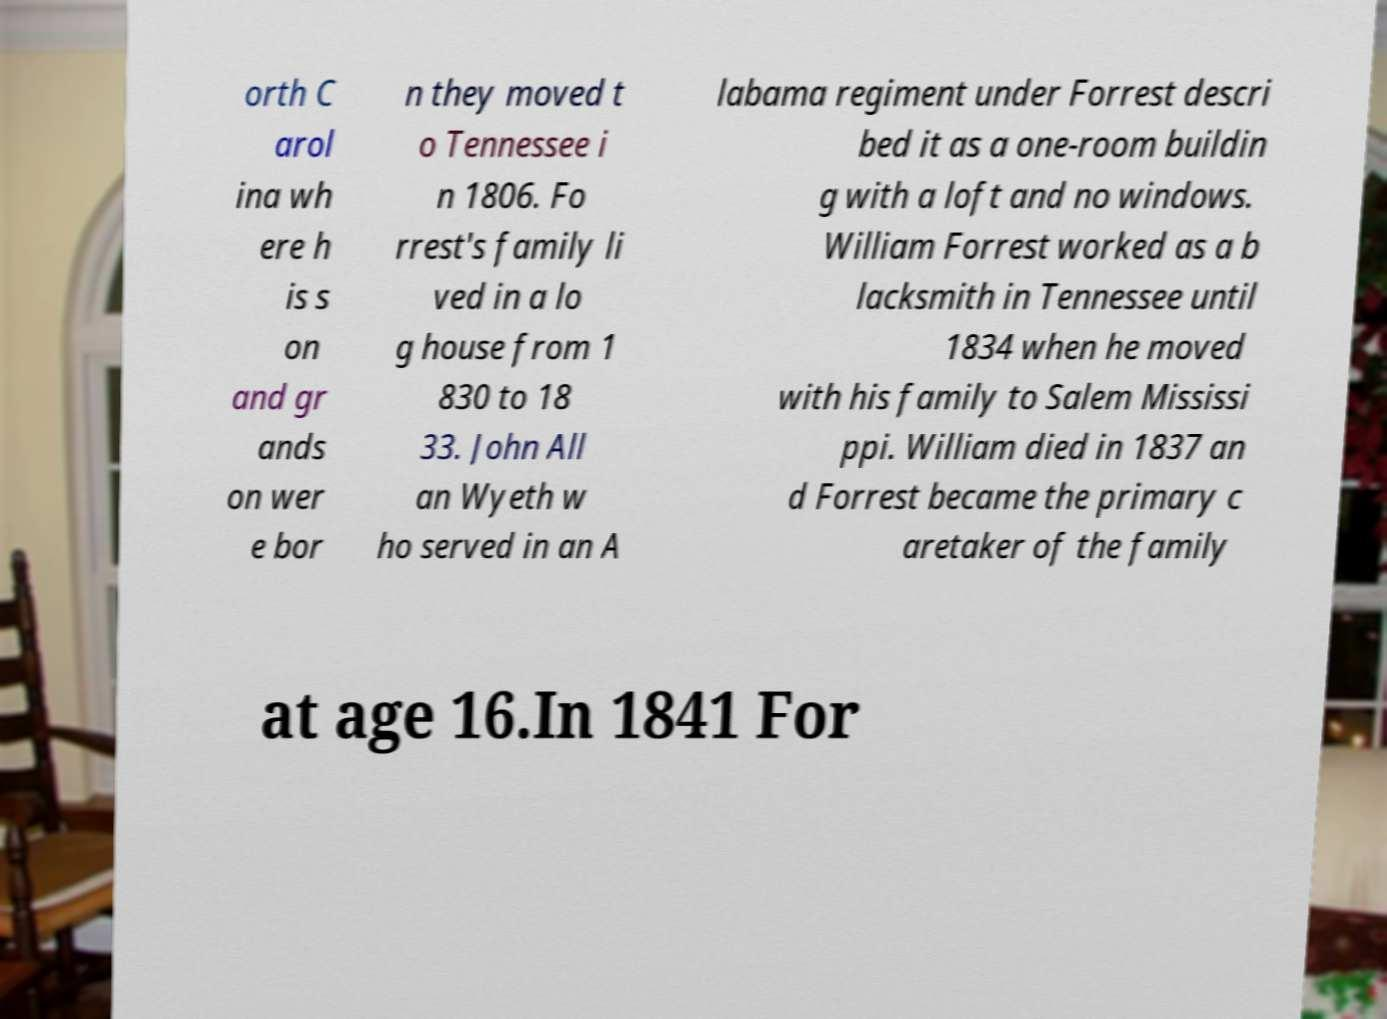Could you extract and type out the text from this image? orth C arol ina wh ere h is s on and gr ands on wer e bor n they moved t o Tennessee i n 1806. Fo rrest's family li ved in a lo g house from 1 830 to 18 33. John All an Wyeth w ho served in an A labama regiment under Forrest descri bed it as a one-room buildin g with a loft and no windows. William Forrest worked as a b lacksmith in Tennessee until 1834 when he moved with his family to Salem Mississi ppi. William died in 1837 an d Forrest became the primary c aretaker of the family at age 16.In 1841 For 